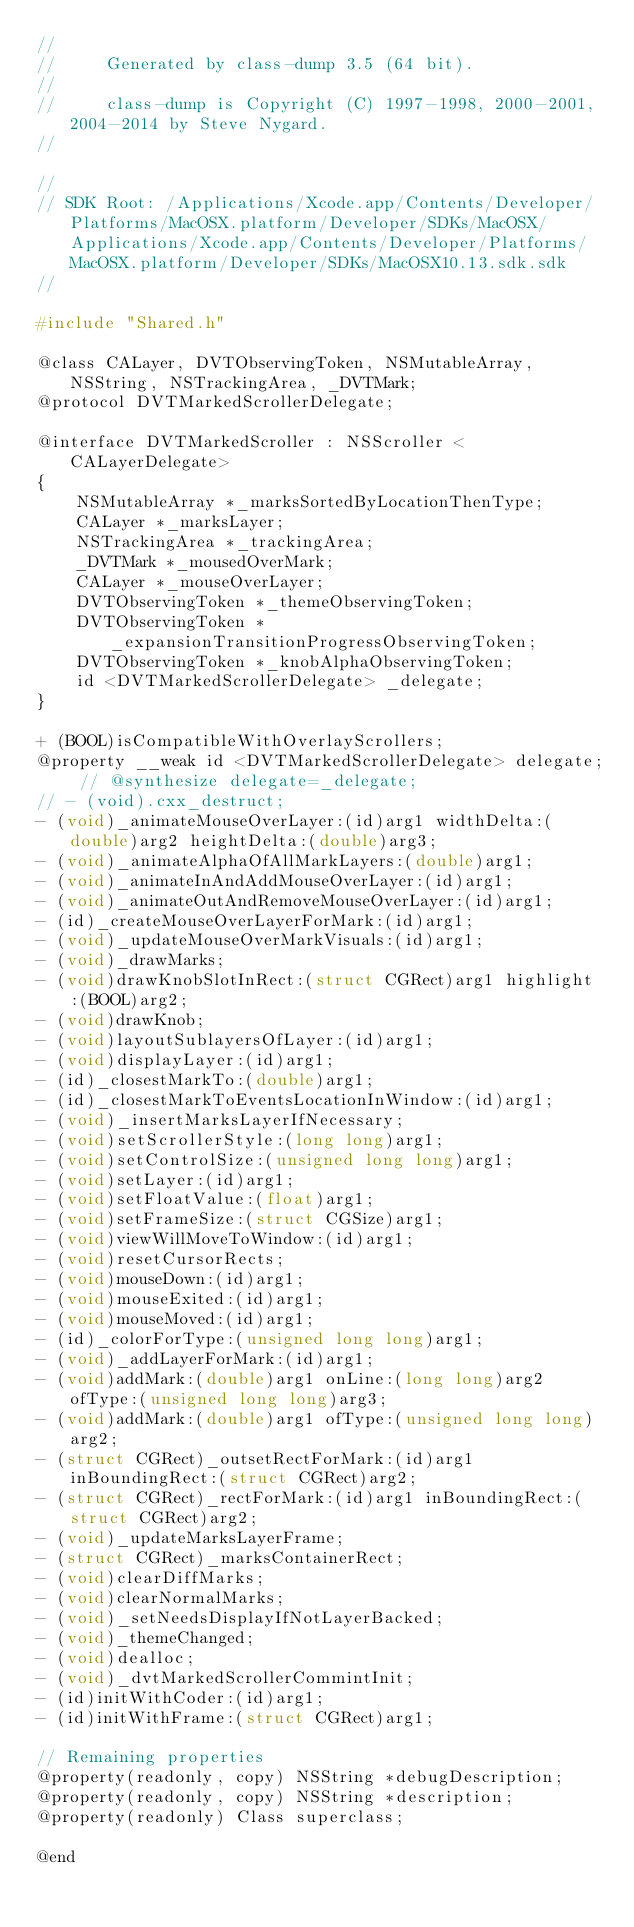Convert code to text. <code><loc_0><loc_0><loc_500><loc_500><_C_>//
//     Generated by class-dump 3.5 (64 bit).
//
//     class-dump is Copyright (C) 1997-1998, 2000-2001, 2004-2014 by Steve Nygard.
//

//
// SDK Root: /Applications/Xcode.app/Contents/Developer/Platforms/MacOSX.platform/Developer/SDKs/MacOSX/Applications/Xcode.app/Contents/Developer/Platforms/MacOSX.platform/Developer/SDKs/MacOSX10.13.sdk.sdk
//

#include "Shared.h"

@class CALayer, DVTObservingToken, NSMutableArray, NSString, NSTrackingArea, _DVTMark;
@protocol DVTMarkedScrollerDelegate;

@interface DVTMarkedScroller : NSScroller <CALayerDelegate>
{
    NSMutableArray *_marksSortedByLocationThenType;
    CALayer *_marksLayer;
    NSTrackingArea *_trackingArea;
    _DVTMark *_mousedOverMark;
    CALayer *_mouseOverLayer;
    DVTObservingToken *_themeObservingToken;
    DVTObservingToken *_expansionTransitionProgressObservingToken;
    DVTObservingToken *_knobAlphaObservingToken;
    id <DVTMarkedScrollerDelegate> _delegate;
}

+ (BOOL)isCompatibleWithOverlayScrollers;
@property __weak id <DVTMarkedScrollerDelegate> delegate; // @synthesize delegate=_delegate;
// - (void).cxx_destruct;
- (void)_animateMouseOverLayer:(id)arg1 widthDelta:(double)arg2 heightDelta:(double)arg3;
- (void)_animateAlphaOfAllMarkLayers:(double)arg1;
- (void)_animateInAndAddMouseOverLayer:(id)arg1;
- (void)_animateOutAndRemoveMouseOverLayer:(id)arg1;
- (id)_createMouseOverLayerForMark:(id)arg1;
- (void)_updateMouseOverMarkVisuals:(id)arg1;
- (void)_drawMarks;
- (void)drawKnobSlotInRect:(struct CGRect)arg1 highlight:(BOOL)arg2;
- (void)drawKnob;
- (void)layoutSublayersOfLayer:(id)arg1;
- (void)displayLayer:(id)arg1;
- (id)_closestMarkTo:(double)arg1;
- (id)_closestMarkToEventsLocationInWindow:(id)arg1;
- (void)_insertMarksLayerIfNecessary;
- (void)setScrollerStyle:(long long)arg1;
- (void)setControlSize:(unsigned long long)arg1;
- (void)setLayer:(id)arg1;
- (void)setFloatValue:(float)arg1;
- (void)setFrameSize:(struct CGSize)arg1;
- (void)viewWillMoveToWindow:(id)arg1;
- (void)resetCursorRects;
- (void)mouseDown:(id)arg1;
- (void)mouseExited:(id)arg1;
- (void)mouseMoved:(id)arg1;
- (id)_colorForType:(unsigned long long)arg1;
- (void)_addLayerForMark:(id)arg1;
- (void)addMark:(double)arg1 onLine:(long long)arg2 ofType:(unsigned long long)arg3;
- (void)addMark:(double)arg1 ofType:(unsigned long long)arg2;
- (struct CGRect)_outsetRectForMark:(id)arg1 inBoundingRect:(struct CGRect)arg2;
- (struct CGRect)_rectForMark:(id)arg1 inBoundingRect:(struct CGRect)arg2;
- (void)_updateMarksLayerFrame;
- (struct CGRect)_marksContainerRect;
- (void)clearDiffMarks;
- (void)clearNormalMarks;
- (void)_setNeedsDisplayIfNotLayerBacked;
- (void)_themeChanged;
- (void)dealloc;
- (void)_dvtMarkedScrollerCommintInit;
- (id)initWithCoder:(id)arg1;
- (id)initWithFrame:(struct CGRect)arg1;

// Remaining properties
@property(readonly, copy) NSString *debugDescription;
@property(readonly, copy) NSString *description;
@property(readonly) Class superclass;

@end

</code> 